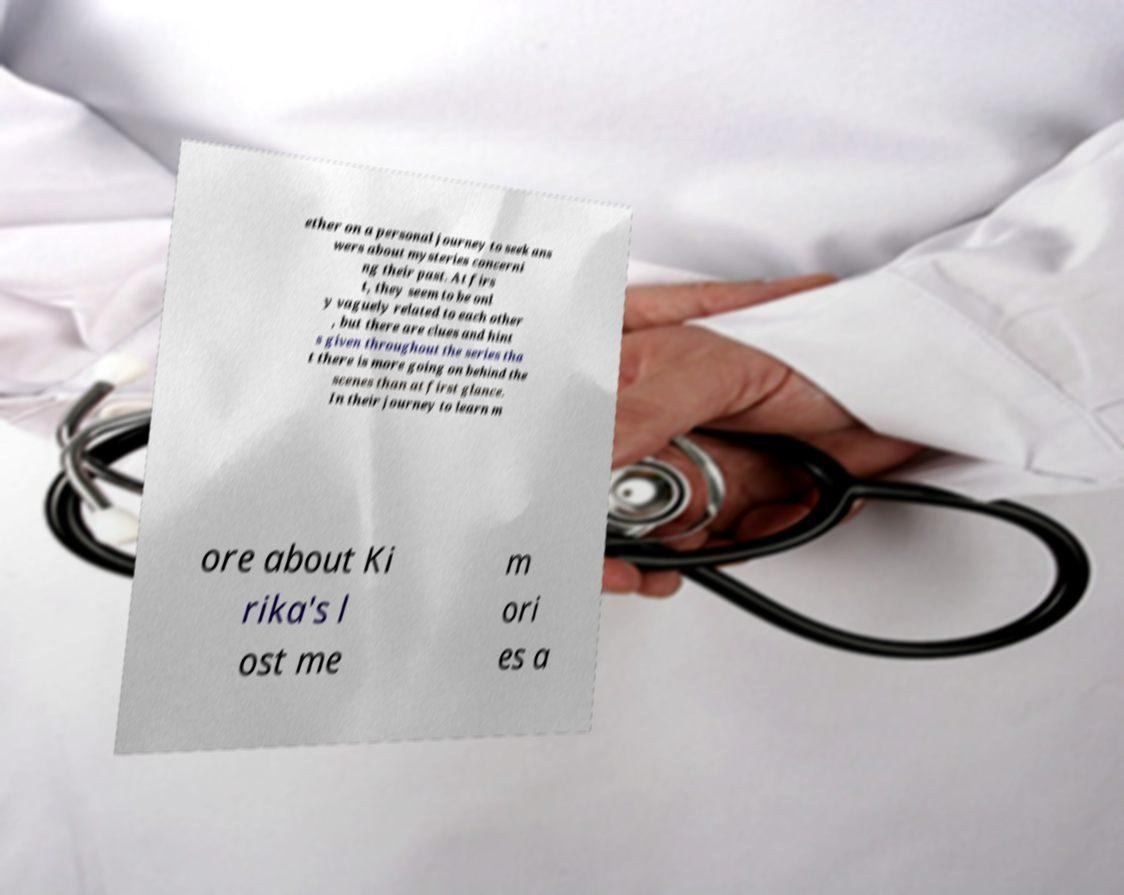What messages or text are displayed in this image? I need them in a readable, typed format. ether on a personal journey to seek ans wers about mysteries concerni ng their past. At firs t, they seem to be onl y vaguely related to each other , but there are clues and hint s given throughout the series tha t there is more going on behind the scenes than at first glance. In their journey to learn m ore about Ki rika's l ost me m ori es a 